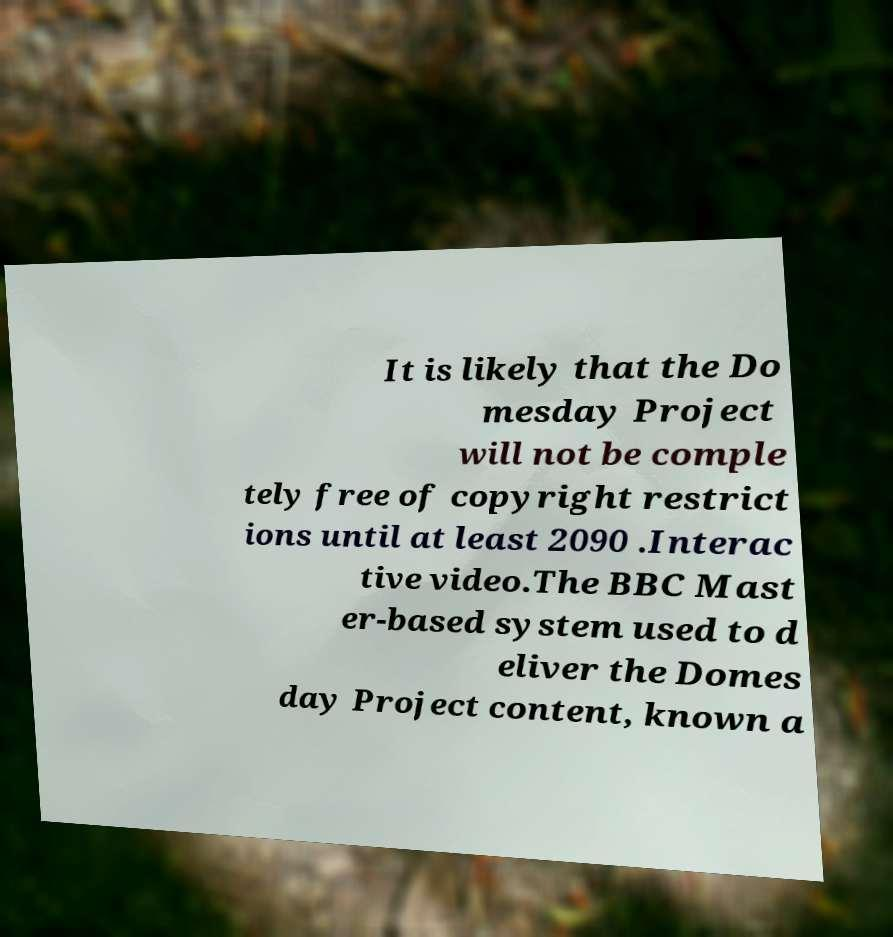I need the written content from this picture converted into text. Can you do that? It is likely that the Do mesday Project will not be comple tely free of copyright restrict ions until at least 2090 .Interac tive video.The BBC Mast er-based system used to d eliver the Domes day Project content, known a 